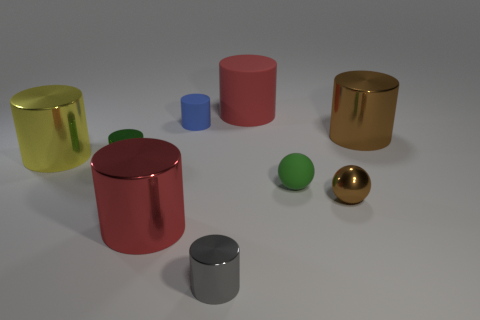Subtract all brown metal cylinders. How many cylinders are left? 6 Add 1 tiny gray shiny cylinders. How many objects exist? 10 Subtract all brown cylinders. How many cylinders are left? 6 Subtract all brown cylinders. Subtract all green blocks. How many cylinders are left? 6 Subtract all cylinders. How many objects are left? 2 Subtract 0 yellow blocks. How many objects are left? 9 Subtract all large yellow rubber cylinders. Subtract all tiny blue rubber things. How many objects are left? 8 Add 3 green objects. How many green objects are left? 5 Add 9 cubes. How many cubes exist? 9 